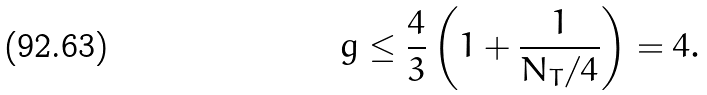<formula> <loc_0><loc_0><loc_500><loc_500>g \leq \frac { 4 } { 3 } \left ( 1 + \frac { 1 } { N _ { T } / 4 } \right ) = 4 .</formula> 